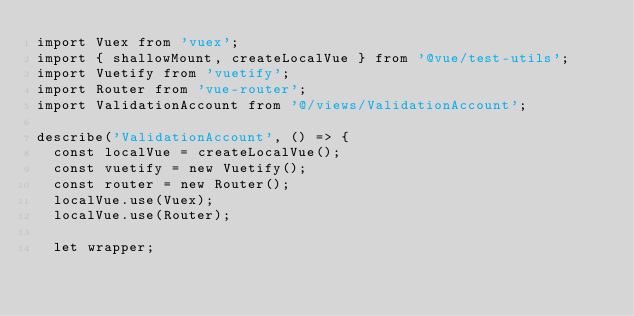<code> <loc_0><loc_0><loc_500><loc_500><_JavaScript_>import Vuex from 'vuex';
import { shallowMount, createLocalVue } from '@vue/test-utils';
import Vuetify from 'vuetify';
import Router from 'vue-router';
import ValidationAccount from '@/views/ValidationAccount';

describe('ValidationAccount', () => {
  const localVue = createLocalVue();
  const vuetify = new Vuetify();
  const router = new Router();
  localVue.use(Vuex);
  localVue.use(Router);

  let wrapper;
</code> 